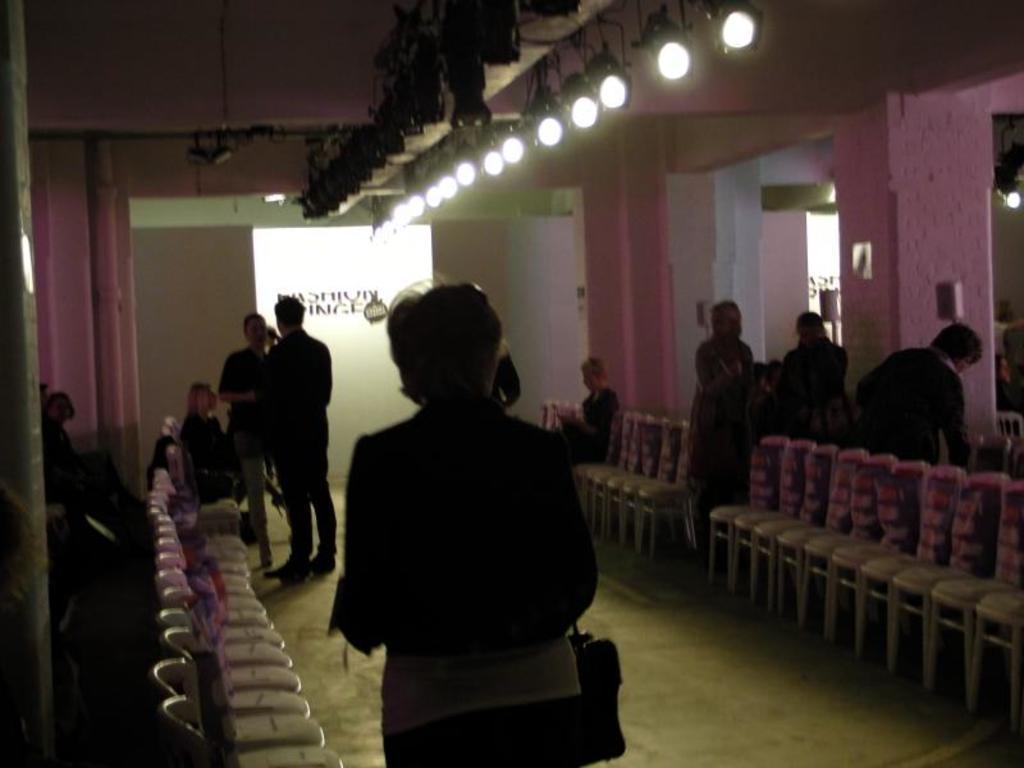What is the position of the person in the image? There is a person standing on the floor. Can you describe the position of the woman in the image? There is a woman sitting in the image. How many people are standing in the image? There is a group of people standing in the image. What can be seen above the woman in the image? Lights are present above the woman. How many bikes are parked next to the woman in the image? There are no bikes present in the image. What type of food is the cook preparing in the image? There is no cook or food preparation visible in the image. 